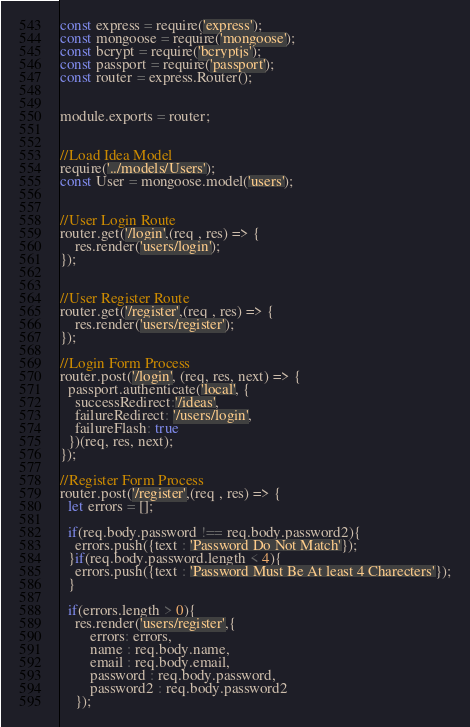<code> <loc_0><loc_0><loc_500><loc_500><_JavaScript_>const express = require('express');
const mongoose = require('mongoose');
const bcrypt = require('bcryptjs');
const passport = require('passport');
const router = express.Router();


module.exports = router;


//Load Idea Model
require('../models/Users');
const User = mongoose.model('users');


//User Login Route
router.get('/login',(req , res) => {
	res.render('users/login');
});


//User Register Route
router.get('/register',(req , res) => {
	res.render('users/register');
});

//Login Form Process
router.post('/login', (req, res, next) => {
  passport.authenticate('local', {
    successRedirect:'/ideas',
    failureRedirect: '/users/login',
    failureFlash: true
  })(req, res, next);
});

//Register Form Process
router.post('/register',(req , res) => {
  let errors = [];

  if(req.body.password !== req.body.password2){
  	errors.push({text : 'Password Do Not Match'});
  }if(req.body.password.length < 4){
  	errors.push({text : 'Password Must Be At least 4 Charecters'});
  }

  if(errors.length > 0){
  	res.render('users/register',{
  		errors: errors,
  		name : req.body.name,
  		email : req.body.email,
  		password : req.body.password,
  		password2 : req.body.password2
  	});</code> 